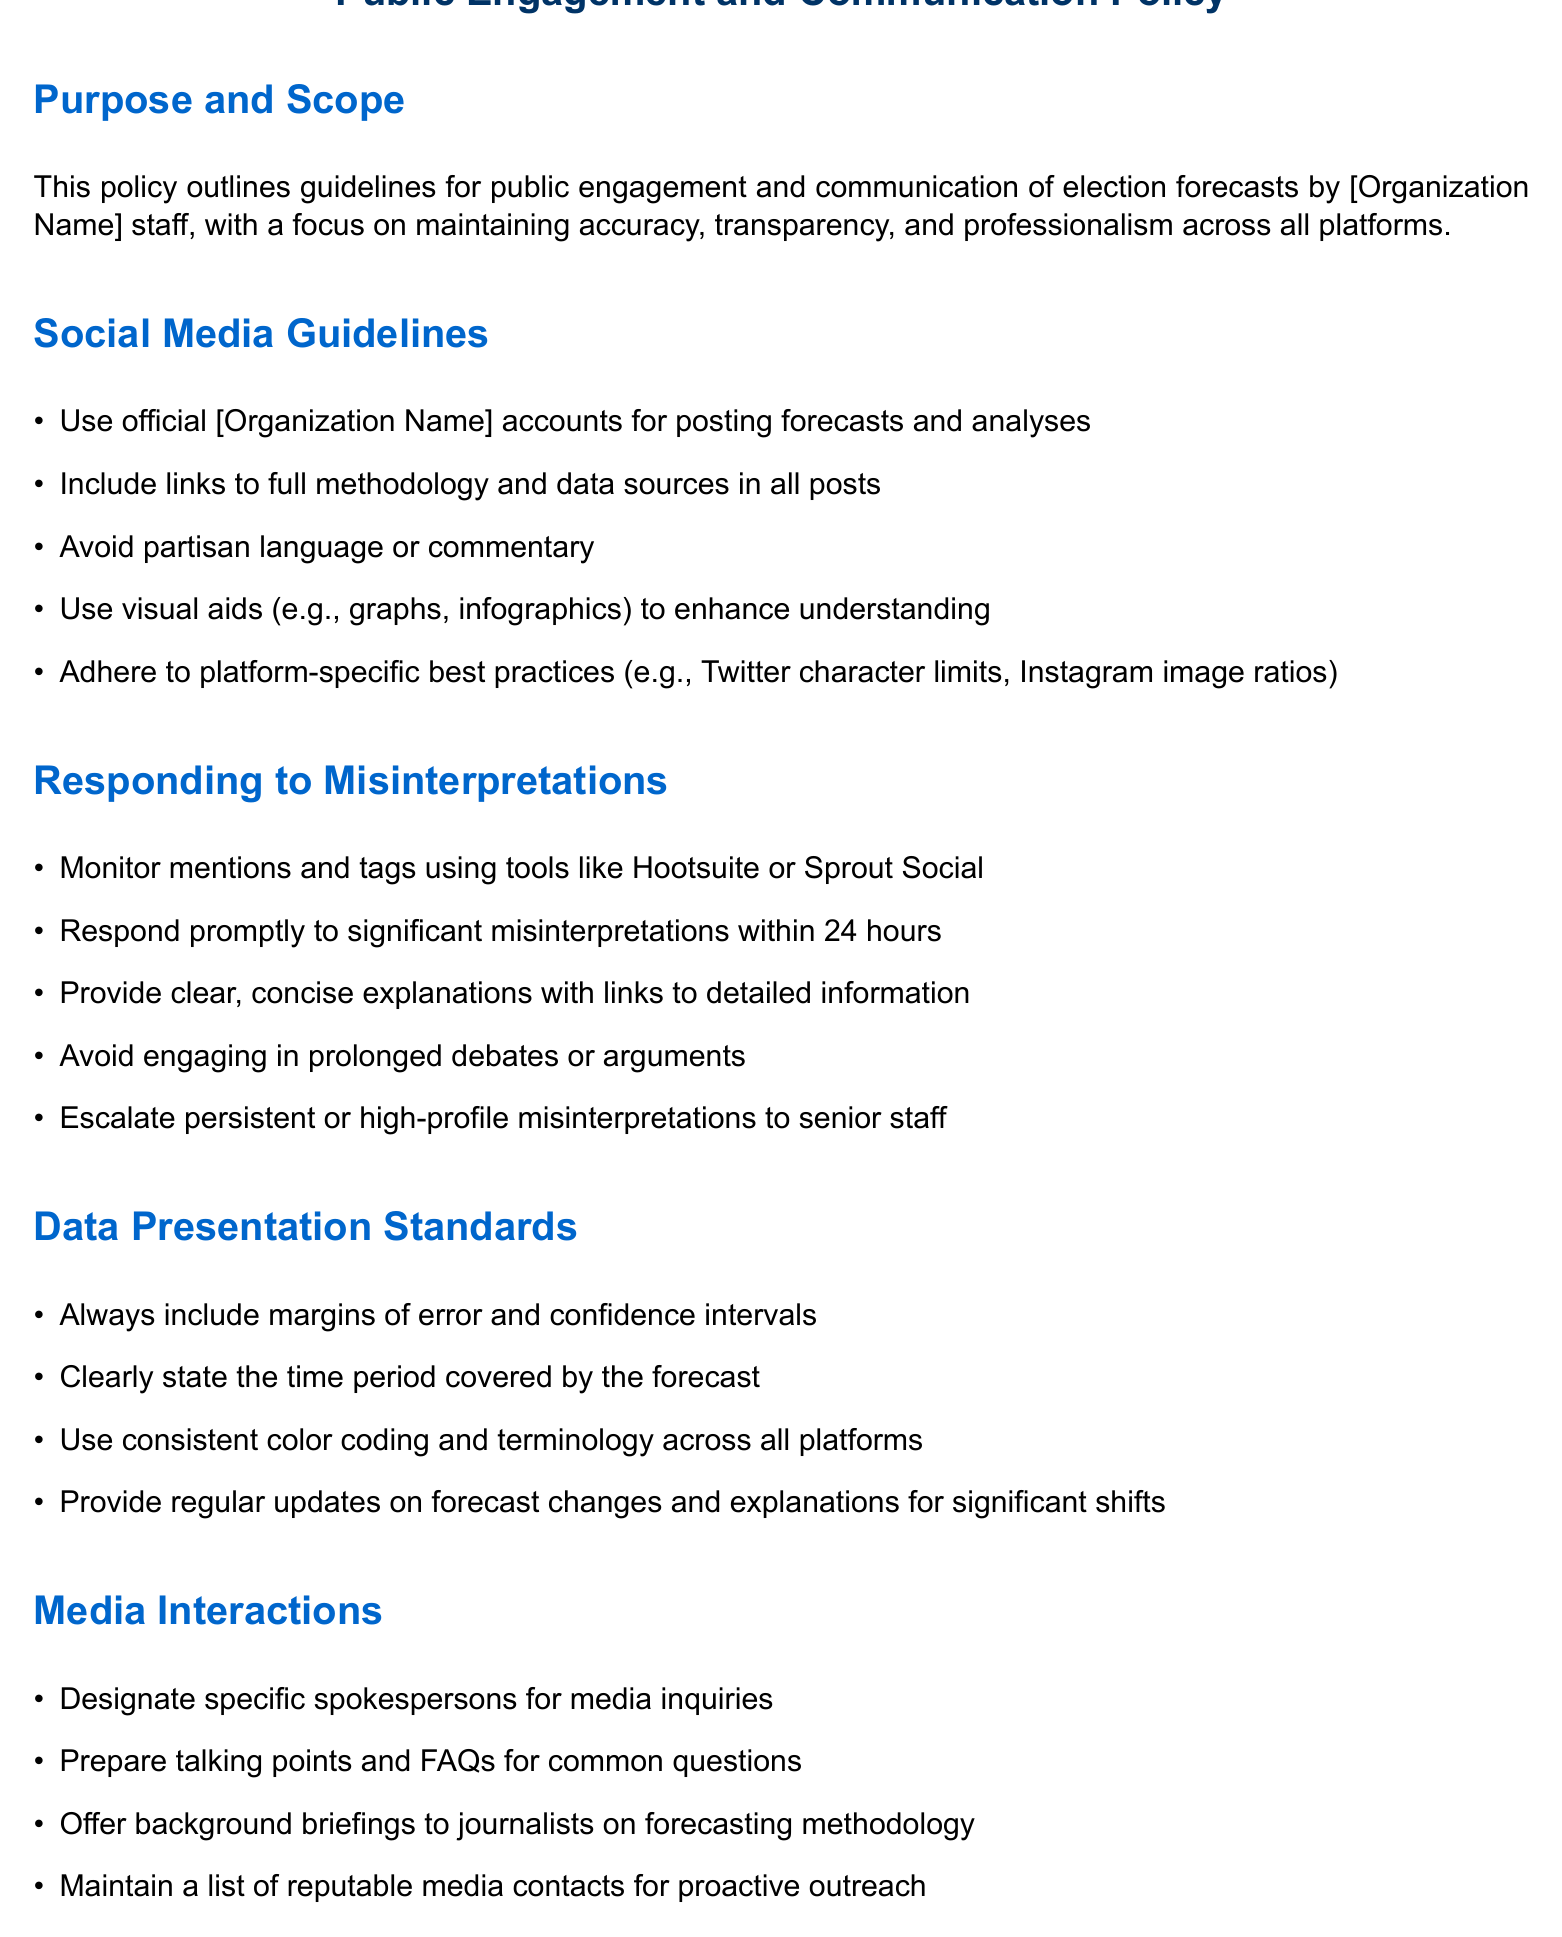What is the main purpose of the policy? The policy outlines guidelines for public engagement and communication of election forecasts by [Organization Name] staff, focusing on accuracy, transparency, and professionalism.
Answer: guidelines for public engagement and communication How long should responses to significant misinterpretations take? The document states that responses to significant misinterpretations should be made promptly, specifically within a time frame.
Answer: 24 hours What should be included in social media posts? The guidelines specify that all posts must include links to something important for full understanding of the forecasts.
Answer: full methodology and data sources What should be included in data presentations? The document outlines standards regarding the information that must accompany forecast presentations, emphasizing important statistical measures.
Answer: margins of error and confidence intervals What should be avoided in social media communication? The guidelines stipulate a specific type of language to be avoided in posts to maintain neutrality and professionalism.
Answer: partisan language or commentary What is a recommended practice for media interactions? The document provides a specific suggestion regarding interactions with media personnel, focusing on preparation.
Answer: Prepare talking points and FAQs What tool can be used to monitor social media mentions? The policy suggests using a specific type of software for monitoring mentions on social media.
Answer: Hootsuite or Sprout Social Who should handle media inquiries according to the policy? The document designates a particular role for the responsibility of handling inquiries from the media.
Answer: specific spokespersons 